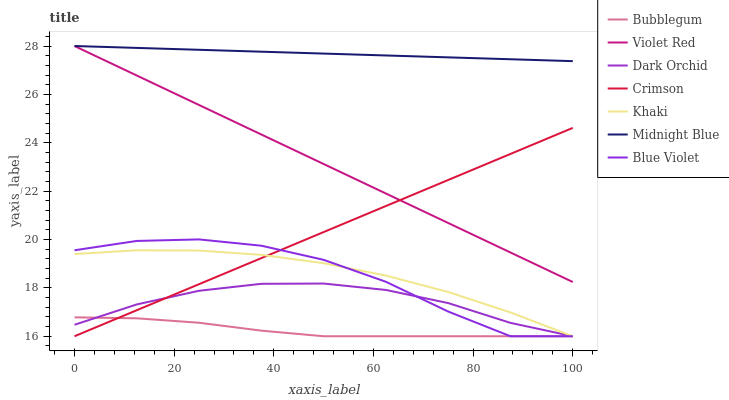Does Bubblegum have the minimum area under the curve?
Answer yes or no. Yes. Does Midnight Blue have the maximum area under the curve?
Answer yes or no. Yes. Does Khaki have the minimum area under the curve?
Answer yes or no. No. Does Khaki have the maximum area under the curve?
Answer yes or no. No. Is Violet Red the smoothest?
Answer yes or no. Yes. Is Blue Violet the roughest?
Answer yes or no. Yes. Is Khaki the smoothest?
Answer yes or no. No. Is Khaki the roughest?
Answer yes or no. No. Does Khaki have the lowest value?
Answer yes or no. Yes. Does Midnight Blue have the lowest value?
Answer yes or no. No. Does Midnight Blue have the highest value?
Answer yes or no. Yes. Does Khaki have the highest value?
Answer yes or no. No. Is Dark Orchid less than Violet Red?
Answer yes or no. Yes. Is Violet Red greater than Khaki?
Answer yes or no. Yes. Does Crimson intersect Bubblegum?
Answer yes or no. Yes. Is Crimson less than Bubblegum?
Answer yes or no. No. Is Crimson greater than Bubblegum?
Answer yes or no. No. Does Dark Orchid intersect Violet Red?
Answer yes or no. No. 